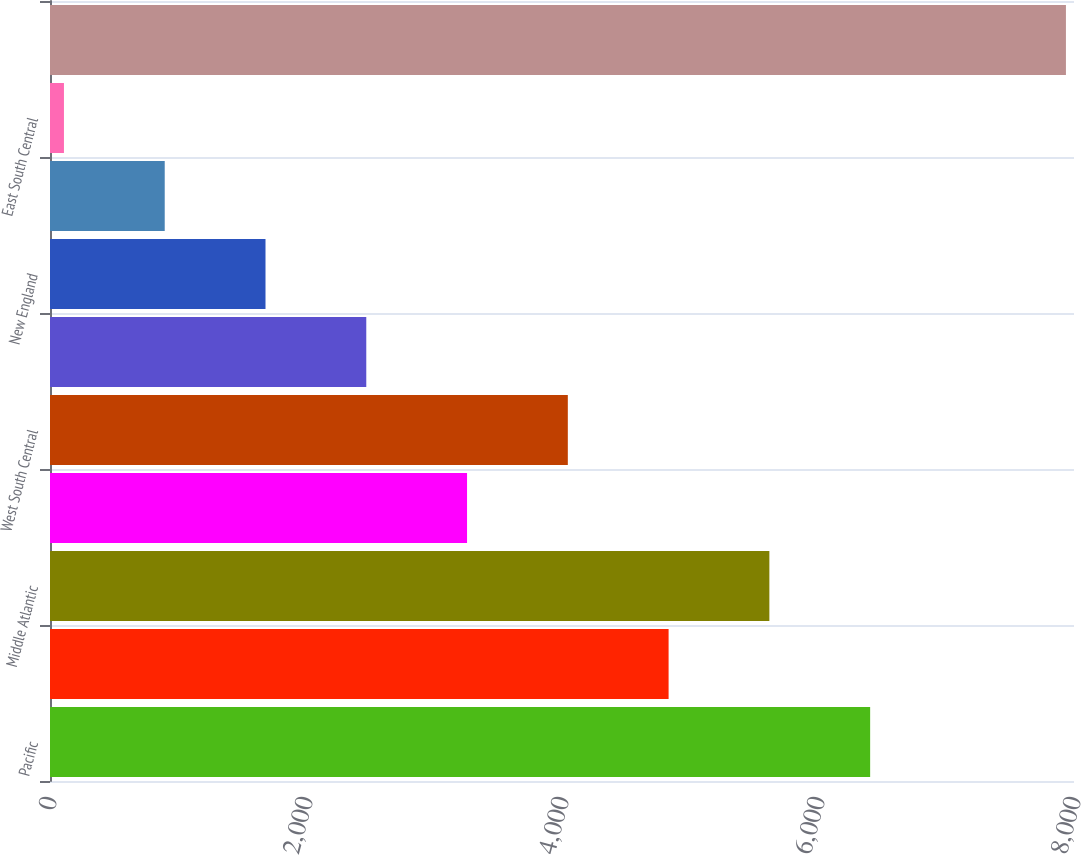Convert chart to OTSL. <chart><loc_0><loc_0><loc_500><loc_500><bar_chart><fcel>Pacific<fcel>South Atlantic<fcel>Middle Atlantic<fcel>East North Central<fcel>West South Central<fcel>Mountain<fcel>New England<fcel>West North Central<fcel>East South Central<fcel>Subtotal-US<nl><fcel>6407.4<fcel>4832.8<fcel>5620.1<fcel>3258.2<fcel>4045.5<fcel>2470.9<fcel>1683.6<fcel>896.3<fcel>109<fcel>7937<nl></chart> 